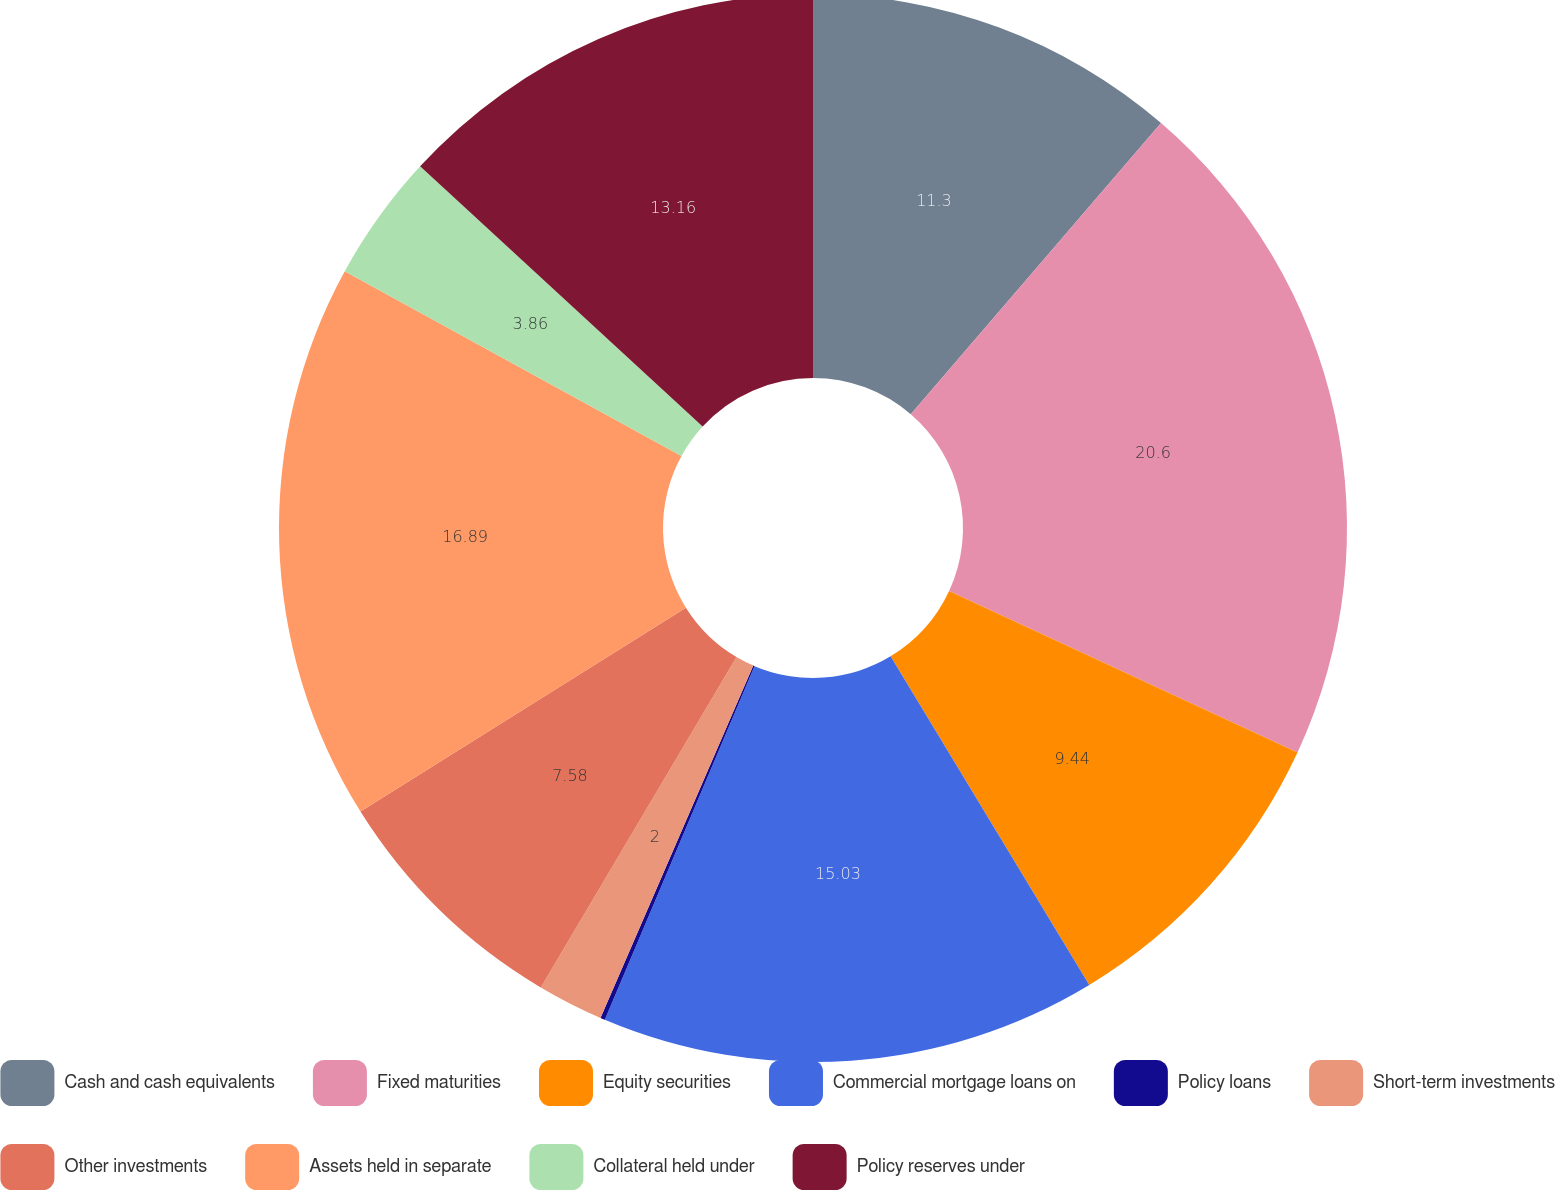<chart> <loc_0><loc_0><loc_500><loc_500><pie_chart><fcel>Cash and cash equivalents<fcel>Fixed maturities<fcel>Equity securities<fcel>Commercial mortgage loans on<fcel>Policy loans<fcel>Short-term investments<fcel>Other investments<fcel>Assets held in separate<fcel>Collateral held under<fcel>Policy reserves under<nl><fcel>11.3%<fcel>20.61%<fcel>9.44%<fcel>15.03%<fcel>0.14%<fcel>2.0%<fcel>7.58%<fcel>16.89%<fcel>3.86%<fcel>13.16%<nl></chart> 